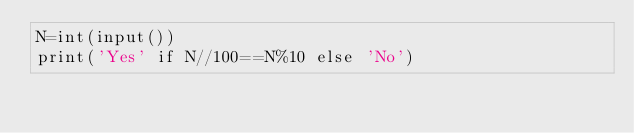<code> <loc_0><loc_0><loc_500><loc_500><_Python_>N=int(input())
print('Yes' if N//100==N%10 else 'No')</code> 